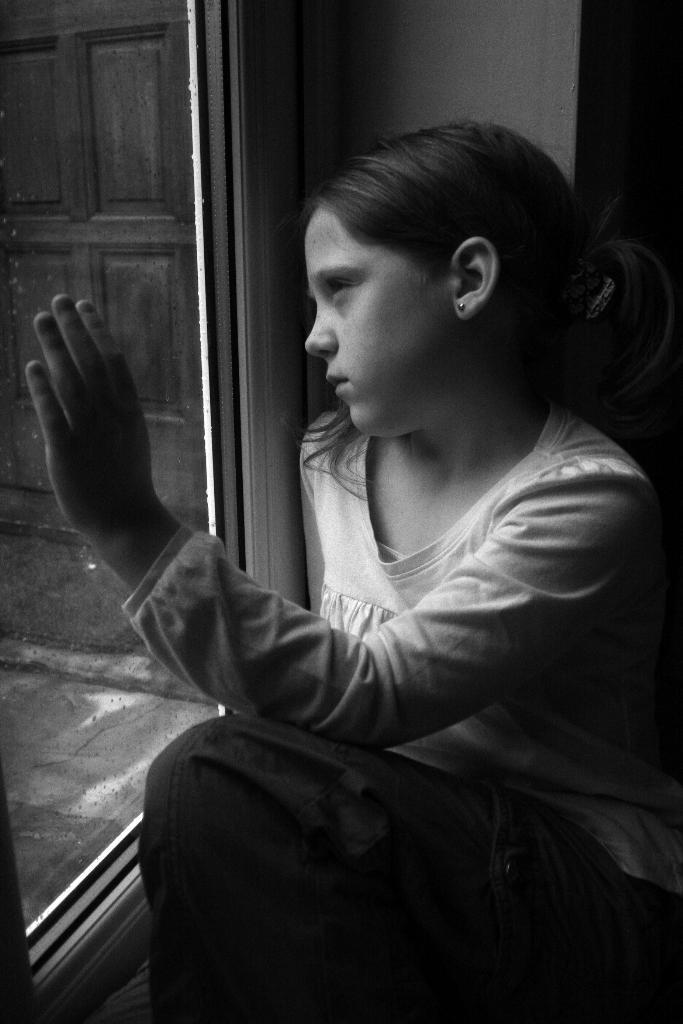Who is the main subject in the image? There is a girl in the image. What is the girl doing in the image? The girl is sitting on the floor. What is the girl touching in the image? The girl has her hand on a glass window. What type of development can be seen in the background of the image? There is no development visible in the background of the image; it only shows the girl sitting on the floor and touching a glass window. 